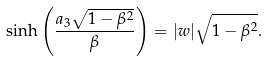<formula> <loc_0><loc_0><loc_500><loc_500>\sinh \left ( \frac { a _ { 3 } \sqrt { 1 - \beta ^ { 2 } } } { \beta } \right ) = | w | \sqrt { 1 - \beta ^ { 2 } } .</formula> 